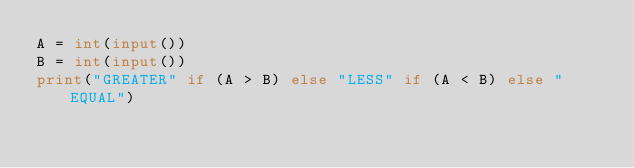<code> <loc_0><loc_0><loc_500><loc_500><_Python_>A = int(input())
B = int(input())
print("GREATER" if (A > B) else "LESS" if (A < B) else "EQUAL")</code> 